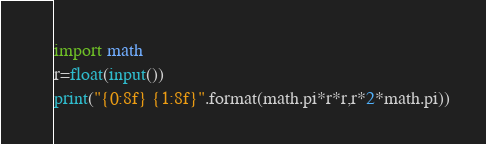Convert code to text. <code><loc_0><loc_0><loc_500><loc_500><_Python_>import math
r=float(input())
print("{0:8f} {1:8f}".format(math.pi*r*r,r*2*math.pi))</code> 